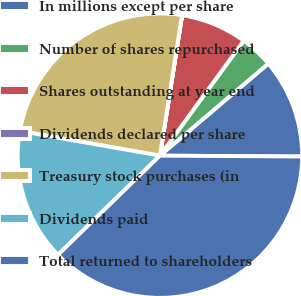<chart> <loc_0><loc_0><loc_500><loc_500><pie_chart><fcel>In millions except per share<fcel>Number of shares repurchased<fcel>Shares outstanding at year end<fcel>Dividends declared per share<fcel>Treasury stock purchases (in<fcel>Dividends paid<fcel>Total returned to shareholders<nl><fcel>11.3%<fcel>3.77%<fcel>7.53%<fcel>0.01%<fcel>24.71%<fcel>15.06%<fcel>37.62%<nl></chart> 